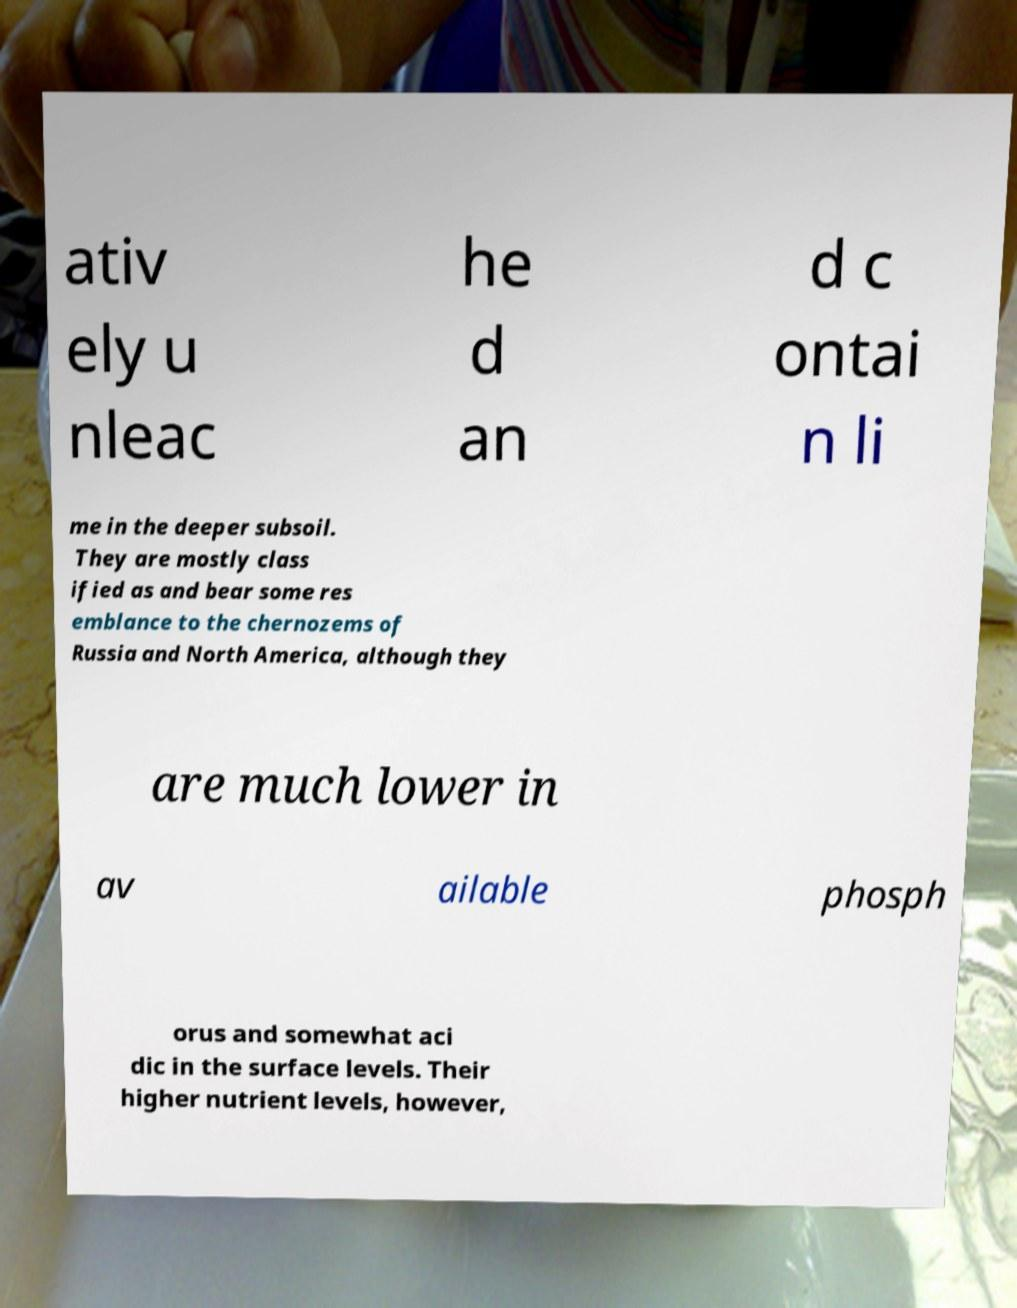There's text embedded in this image that I need extracted. Can you transcribe it verbatim? ativ ely u nleac he d an d c ontai n li me in the deeper subsoil. They are mostly class ified as and bear some res emblance to the chernozems of Russia and North America, although they are much lower in av ailable phosph orus and somewhat aci dic in the surface levels. Their higher nutrient levels, however, 